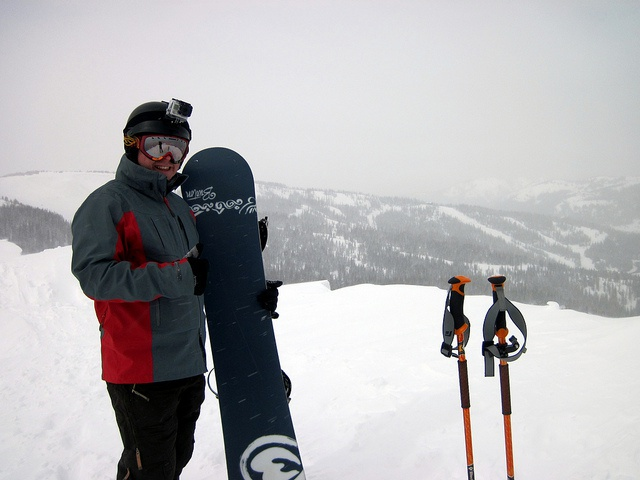Describe the objects in this image and their specific colors. I can see people in darkgray, black, maroon, and darkblue tones and snowboard in darkgray, black, navy, and gray tones in this image. 